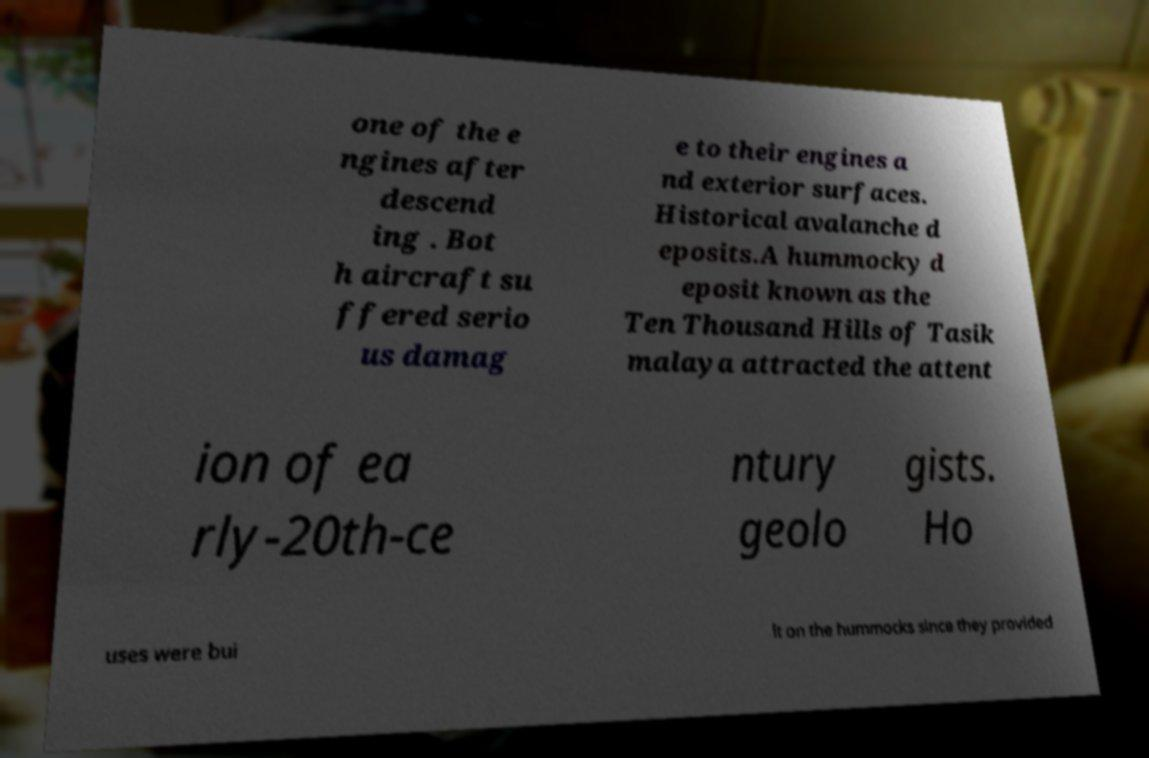There's text embedded in this image that I need extracted. Can you transcribe it verbatim? one of the e ngines after descend ing . Bot h aircraft su ffered serio us damag e to their engines a nd exterior surfaces. Historical avalanche d eposits.A hummocky d eposit known as the Ten Thousand Hills of Tasik malaya attracted the attent ion of ea rly-20th-ce ntury geolo gists. Ho uses were bui lt on the hummocks since they provided 